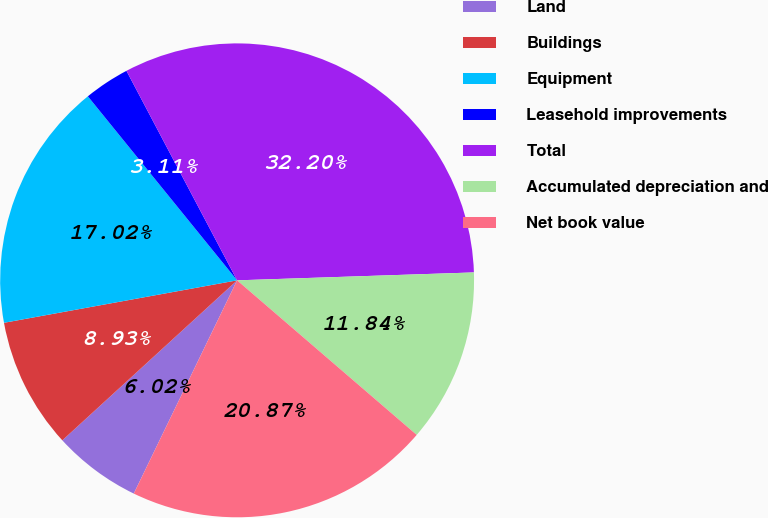<chart> <loc_0><loc_0><loc_500><loc_500><pie_chart><fcel>Land<fcel>Buildings<fcel>Equipment<fcel>Leasehold improvements<fcel>Total<fcel>Accumulated depreciation and<fcel>Net book value<nl><fcel>6.02%<fcel>8.93%<fcel>17.02%<fcel>3.11%<fcel>32.2%<fcel>11.84%<fcel>20.87%<nl></chart> 